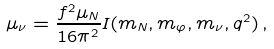Convert formula to latex. <formula><loc_0><loc_0><loc_500><loc_500>\mu _ { \nu } = \frac { f ^ { 2 } \mu _ { N } } { 1 6 \pi ^ { 2 } } I ( m _ { N } , m _ { \varphi } , m _ { \nu } , q ^ { 2 } ) \, ,</formula> 